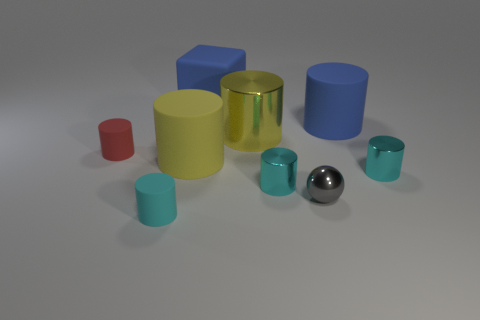Subtract all cyan cylinders. How many were subtracted if there are2cyan cylinders left? 1 Subtract all yellow balls. How many cyan cylinders are left? 3 Subtract 1 cylinders. How many cylinders are left? 6 Subtract all small red rubber cylinders. How many cylinders are left? 6 Subtract all red cylinders. How many cylinders are left? 6 Subtract all blue cylinders. Subtract all gray spheres. How many cylinders are left? 6 Add 1 small gray metal objects. How many objects exist? 10 Subtract all cylinders. How many objects are left? 2 Add 7 red rubber objects. How many red rubber objects exist? 8 Subtract 0 purple cylinders. How many objects are left? 9 